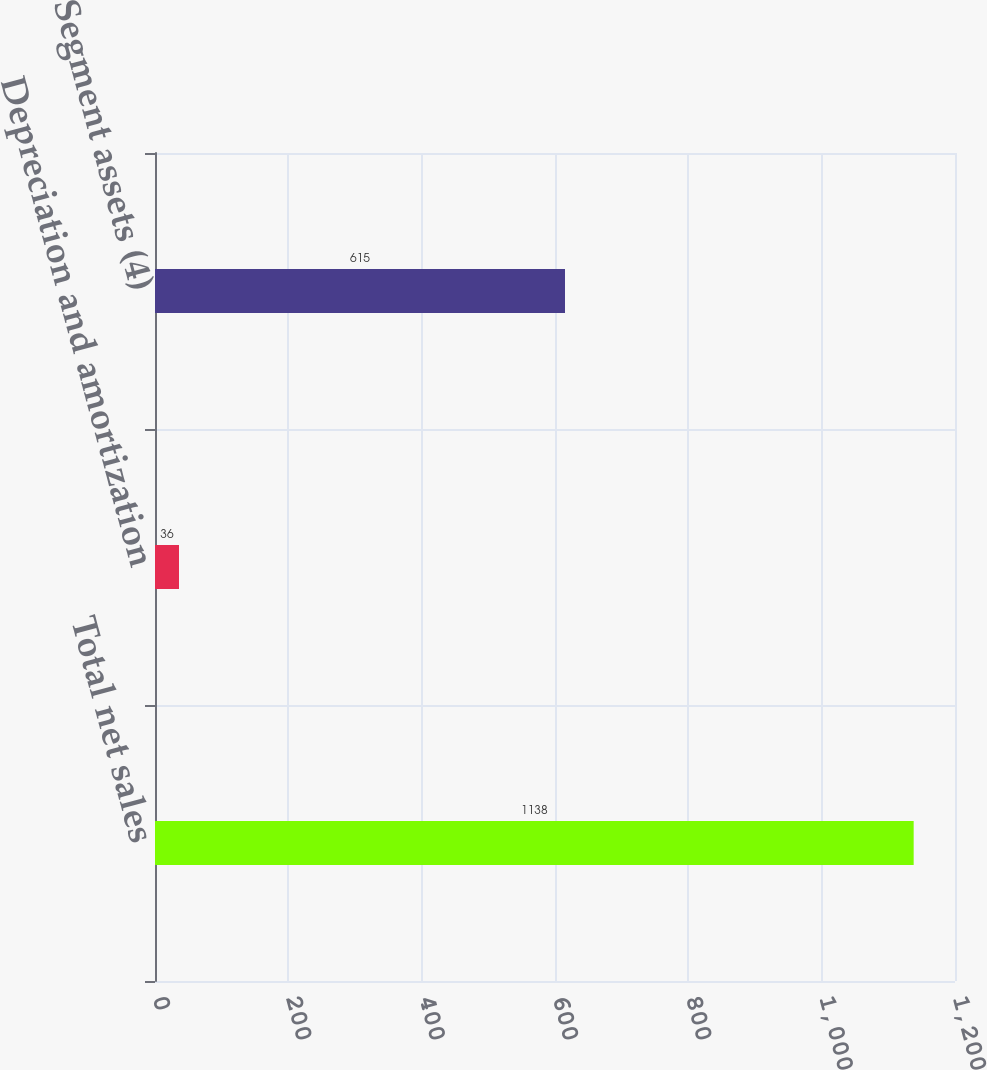Convert chart to OTSL. <chart><loc_0><loc_0><loc_500><loc_500><bar_chart><fcel>Total net sales<fcel>Depreciation and amortization<fcel>Segment assets (4)<nl><fcel>1138<fcel>36<fcel>615<nl></chart> 